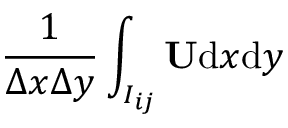<formula> <loc_0><loc_0><loc_500><loc_500>\frac { 1 } { \Delta x \Delta y } \int _ { I _ { i j } } U d x d y</formula> 